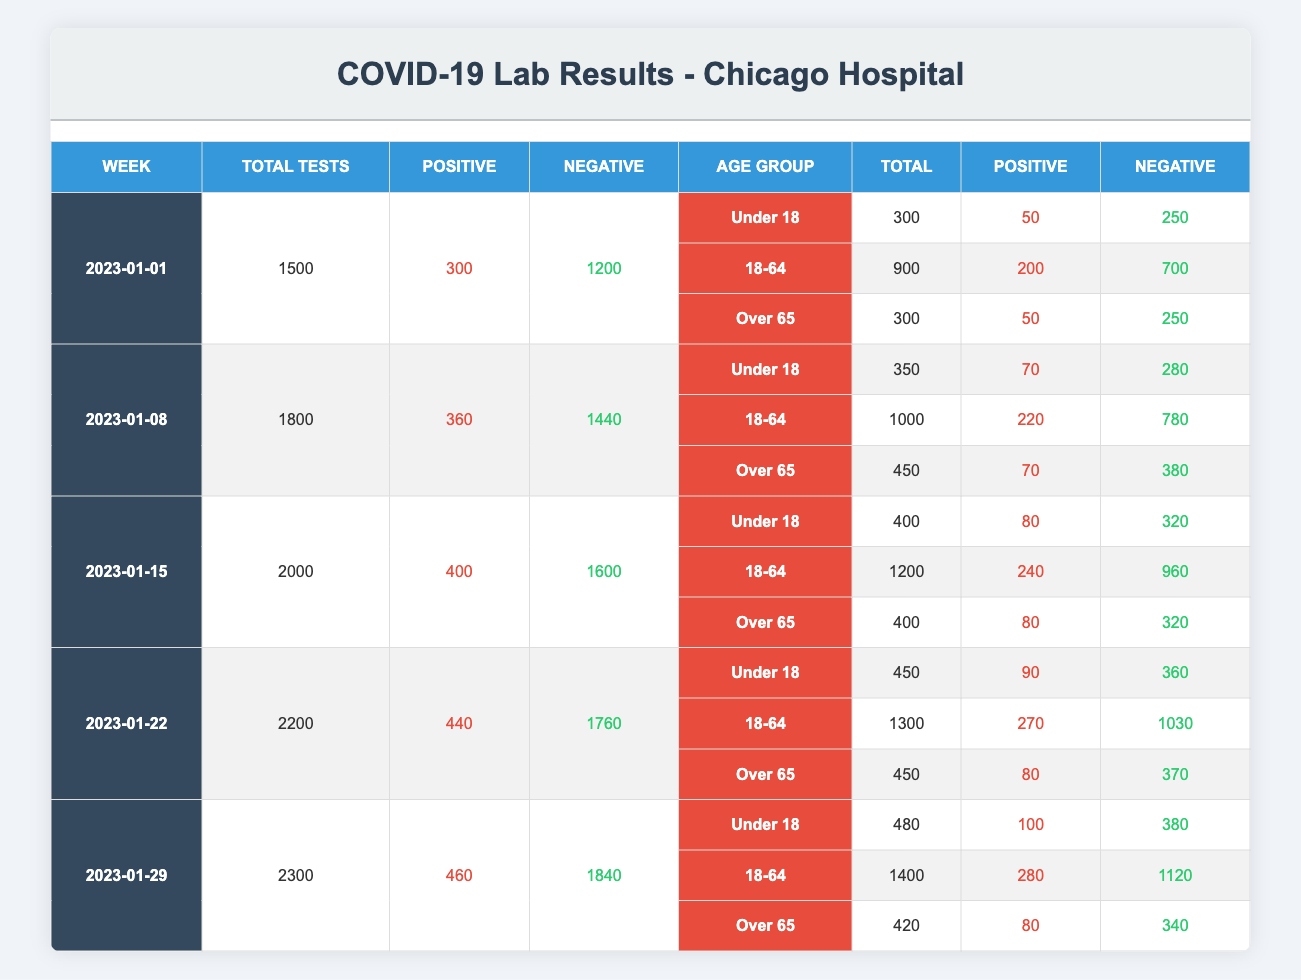how many total tests were conducted in the week of January 15th? By looking at the table under the row for the week of January 15th, the total tests conducted is listed directly in the second column. It shows that 2000 tests were conducted that week.
Answer: 2000 what was the percentage of positive results in the week of January 8th? To calculate the percentage of positive results, divide the number of positive results (360) by the total tests conducted (1800), and then multiply by 100. So, (360 / 1800) * 100 = 20%.
Answer: 20% in which week did the highest number of positive results occur? Looking through the positive results column, the highest value is 460 which corresponds to the week of January 29th. Thus, that week had the highest number of positive results.
Answer: January 29 what is the total number of negative results for all age groups in the week of January 22nd? To find the total negative results in the week of January 22nd, we need to add the negative results for all three age groups: 360 (under 18) + 1030 (18-64) + 370 (over 65) = 1760.
Answer: 1760 did the number of tests conducted increase from January 1st to January 29th? Comparing the total tests conducted for both weeks shows that on January 1st, there were 1500 tests and on January 29th, there were 2300 tests, indicating an increase.
Answer: Yes what is the average number of positive results across the five weeks? To find the average, sum the positive results from each week: (300 + 360 + 400 + 440 + 460) = 1960. Then divide by the number of weeks (5): 1960 / 5 = 392.
Answer: 392 how many more negative results were there than positive results in the week of January 15th? In the week of January 15th, the table shows there were 400 positive results and 1600 negative results. The difference is 1600 - 400 = 1200, hence there were 1200 more negative results.
Answer: 1200 which age group had the lowest percentage of positive tests in the week of January 22nd? For January 22nd, the positive percentages must be calculated for each age group: Under 18: (90 / 450) * 100 = 20%, 18-64: (270 / 1300) * 100 = 20.77%, Over 65: (80 / 450) * 100 = 17.78%. The Over 65 age group had the lowest percentage of positive tests.
Answer: Over 65 how did the total tests change from January 8th to January 22nd? The total tests conducted on January 8th was 1800 and on January 22nd it was 2200. The change can be calculated as 2200 - 1800 = 400, indicating an increase of 400 tests.
Answer: Increased by 400 